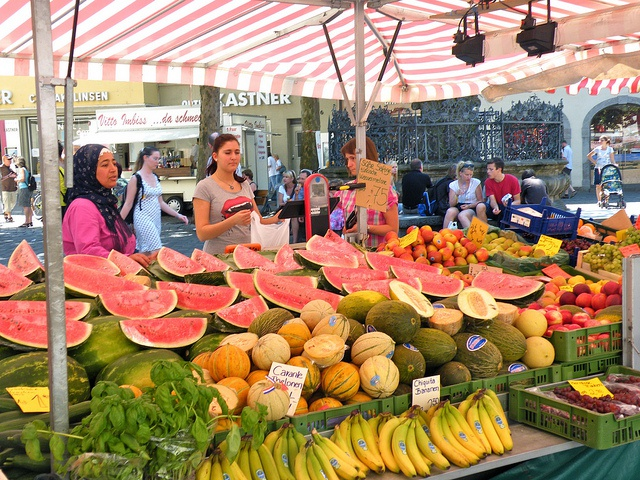Describe the objects in this image and their specific colors. I can see banana in white, orange, and olive tones, people in white, gray, darkgray, and black tones, people in white, black, violet, brown, and salmon tones, people in white, salmon, gray, and lightpink tones, and people in white, darkgray, and lightblue tones in this image. 